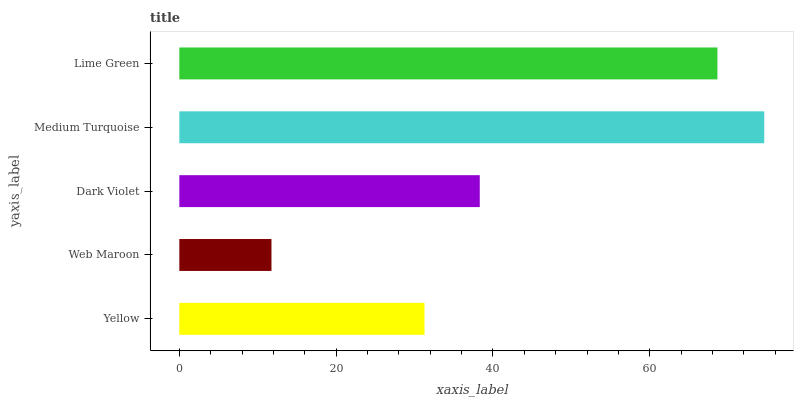Is Web Maroon the minimum?
Answer yes or no. Yes. Is Medium Turquoise the maximum?
Answer yes or no. Yes. Is Dark Violet the minimum?
Answer yes or no. No. Is Dark Violet the maximum?
Answer yes or no. No. Is Dark Violet greater than Web Maroon?
Answer yes or no. Yes. Is Web Maroon less than Dark Violet?
Answer yes or no. Yes. Is Web Maroon greater than Dark Violet?
Answer yes or no. No. Is Dark Violet less than Web Maroon?
Answer yes or no. No. Is Dark Violet the high median?
Answer yes or no. Yes. Is Dark Violet the low median?
Answer yes or no. Yes. Is Yellow the high median?
Answer yes or no. No. Is Yellow the low median?
Answer yes or no. No. 